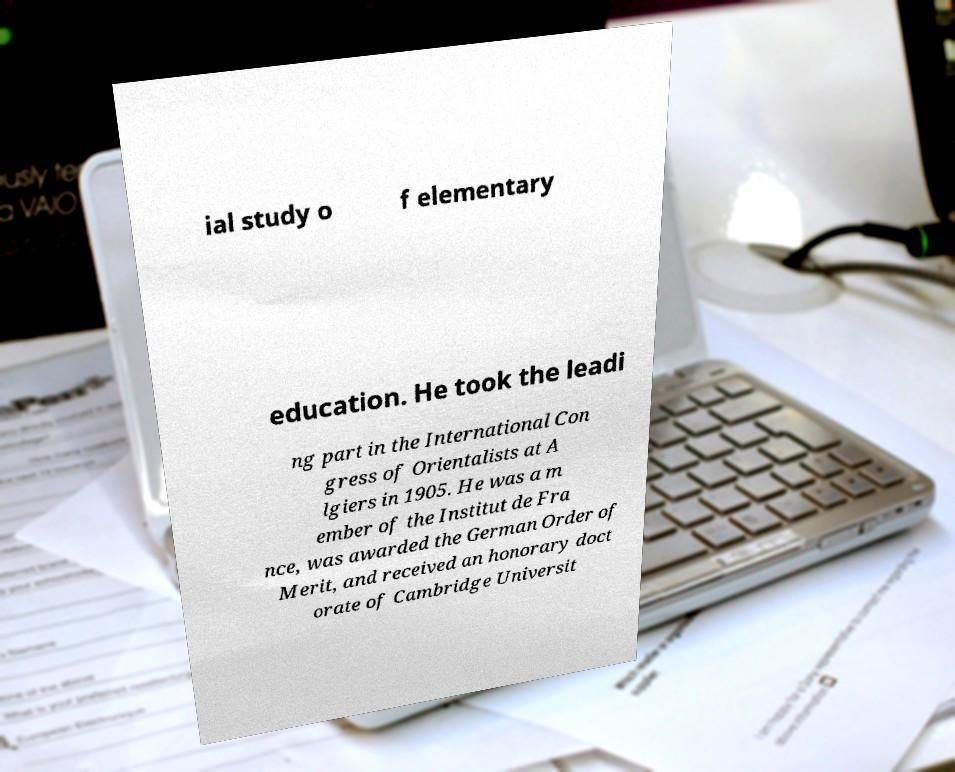I need the written content from this picture converted into text. Can you do that? ial study o f elementary education. He took the leadi ng part in the International Con gress of Orientalists at A lgiers in 1905. He was a m ember of the Institut de Fra nce, was awarded the German Order of Merit, and received an honorary doct orate of Cambridge Universit 